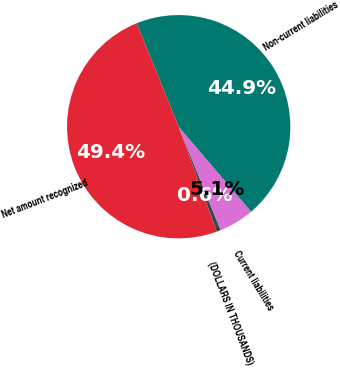<chart> <loc_0><loc_0><loc_500><loc_500><pie_chart><fcel>(DOLLARS IN THOUSANDS)<fcel>Current liabilities<fcel>Non-current liabilities<fcel>Net amount recognized<nl><fcel>0.59%<fcel>5.1%<fcel>44.9%<fcel>49.41%<nl></chart> 